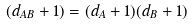<formula> <loc_0><loc_0><loc_500><loc_500>( d _ { A B } + 1 ) = ( d _ { A } + 1 ) ( d _ { B } + 1 )</formula> 